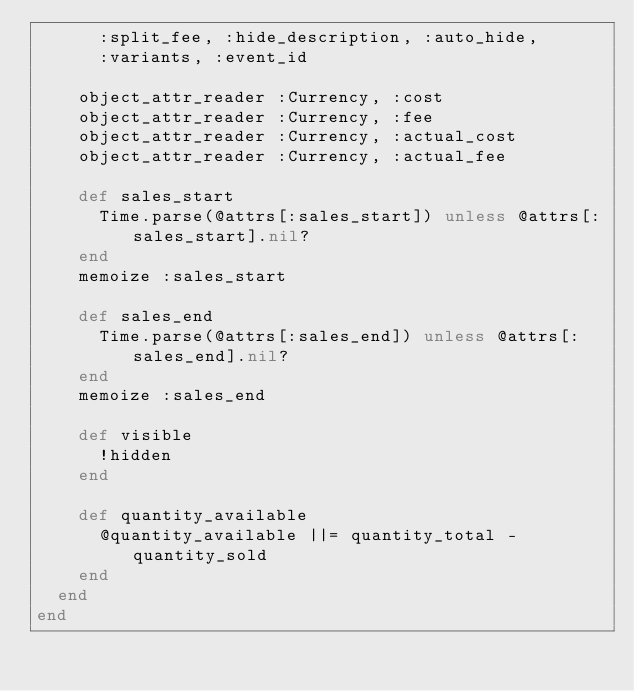Convert code to text. <code><loc_0><loc_0><loc_500><loc_500><_Ruby_>      :split_fee, :hide_description, :auto_hide,
      :variants, :event_id

    object_attr_reader :Currency, :cost
    object_attr_reader :Currency, :fee
    object_attr_reader :Currency, :actual_cost
    object_attr_reader :Currency, :actual_fee

    def sales_start
      Time.parse(@attrs[:sales_start]) unless @attrs[:sales_start].nil?
    end
    memoize :sales_start

    def sales_end
      Time.parse(@attrs[:sales_end]) unless @attrs[:sales_end].nil?
    end
    memoize :sales_end

    def visible
      !hidden
    end

    def quantity_available
      @quantity_available ||= quantity_total - quantity_sold
    end
  end
end</code> 